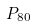Convert formula to latex. <formula><loc_0><loc_0><loc_500><loc_500>P _ { 8 0 }</formula> 